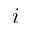<formula> <loc_0><loc_0><loc_500><loc_500>i</formula> 